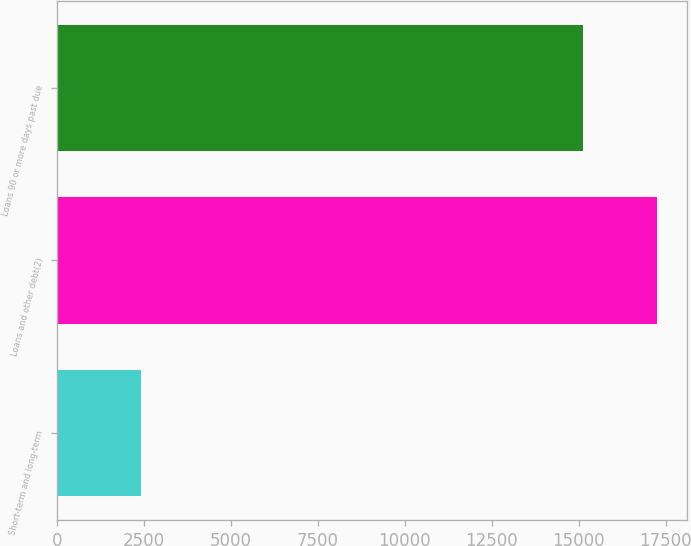Convert chart. <chart><loc_0><loc_0><loc_500><loc_500><bar_chart><fcel>Short-term and long-term<fcel>Loans and other debt(2)<fcel>Loans 90 or more days past due<nl><fcel>2409<fcel>17248<fcel>15113<nl></chart> 